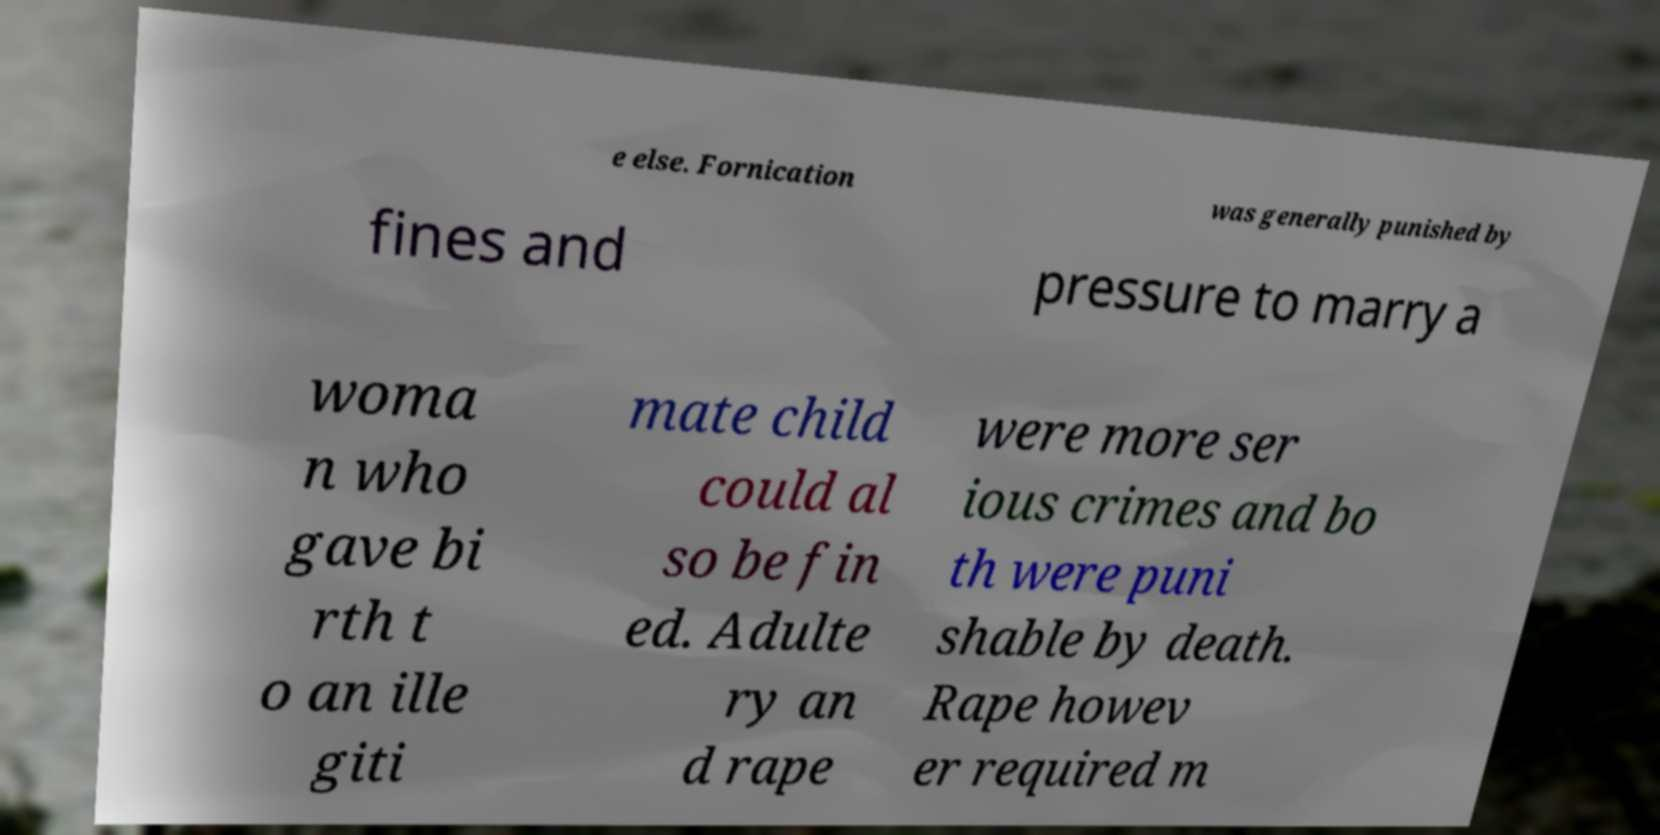There's text embedded in this image that I need extracted. Can you transcribe it verbatim? e else. Fornication was generally punished by fines and pressure to marry a woma n who gave bi rth t o an ille giti mate child could al so be fin ed. Adulte ry an d rape were more ser ious crimes and bo th were puni shable by death. Rape howev er required m 